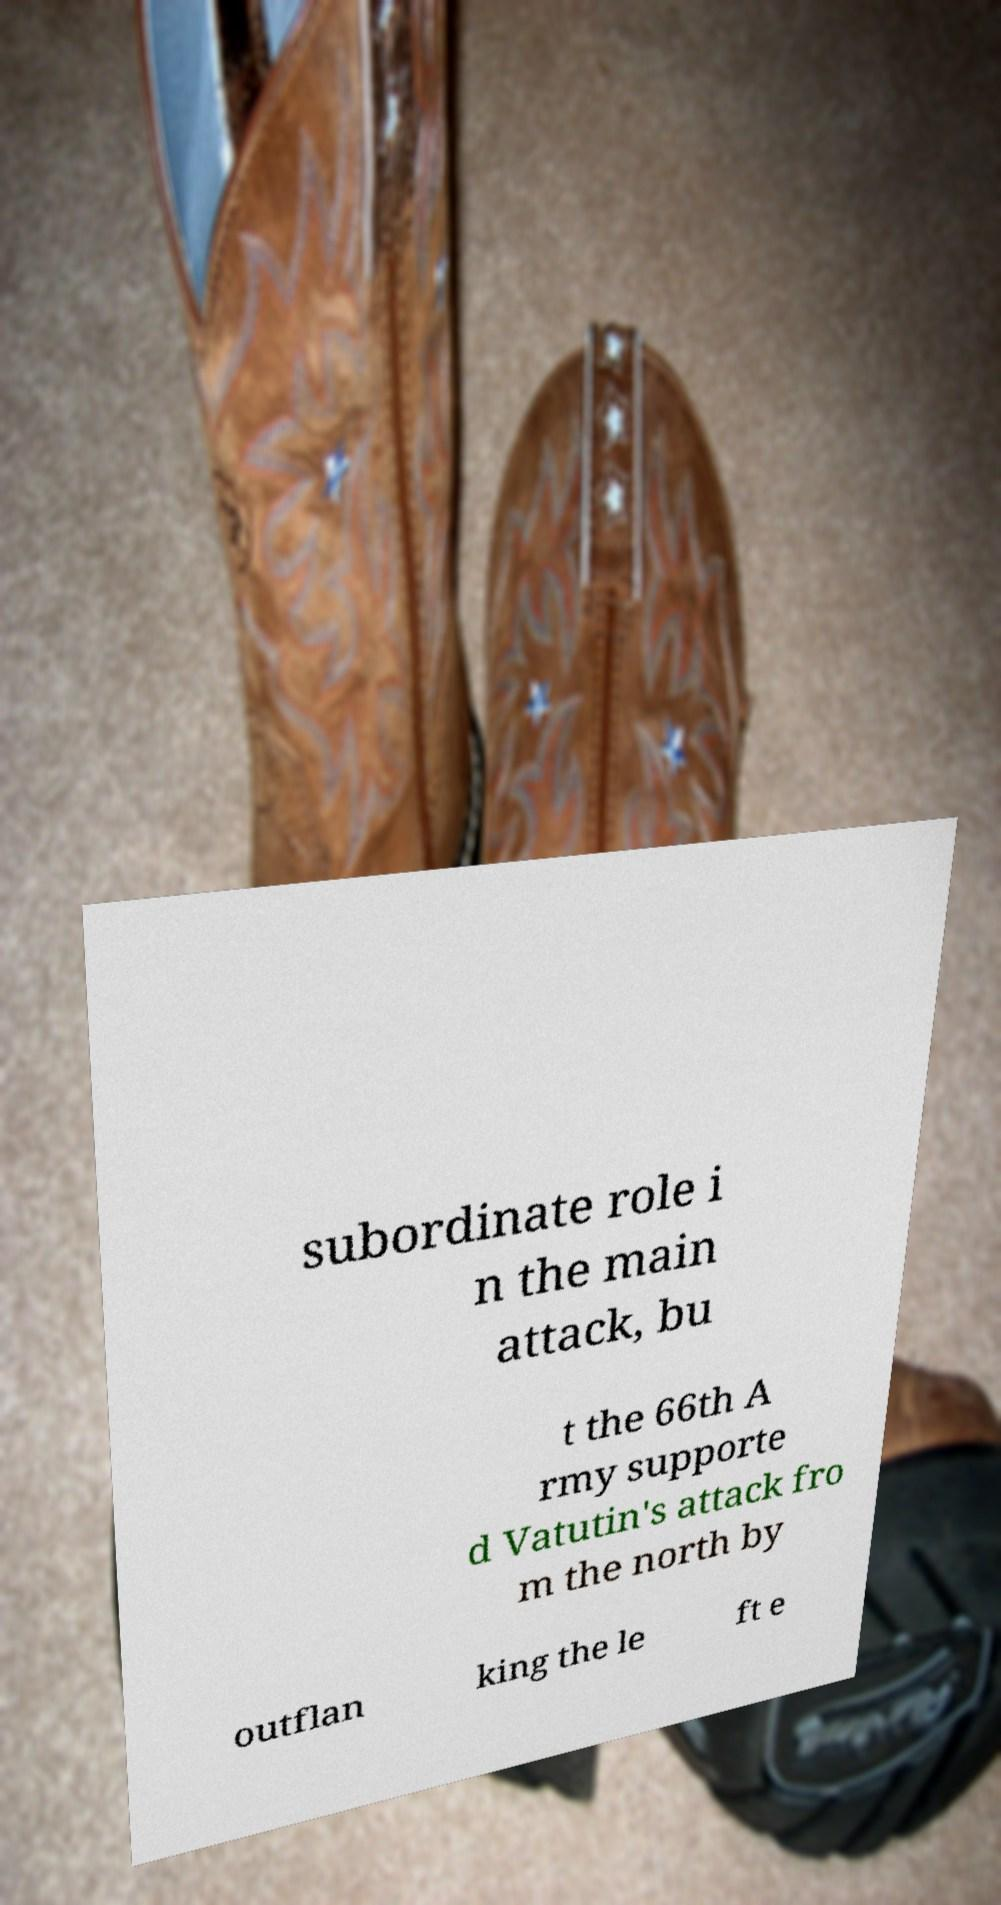For documentation purposes, I need the text within this image transcribed. Could you provide that? subordinate role i n the main attack, bu t the 66th A rmy supporte d Vatutin's attack fro m the north by outflan king the le ft e 